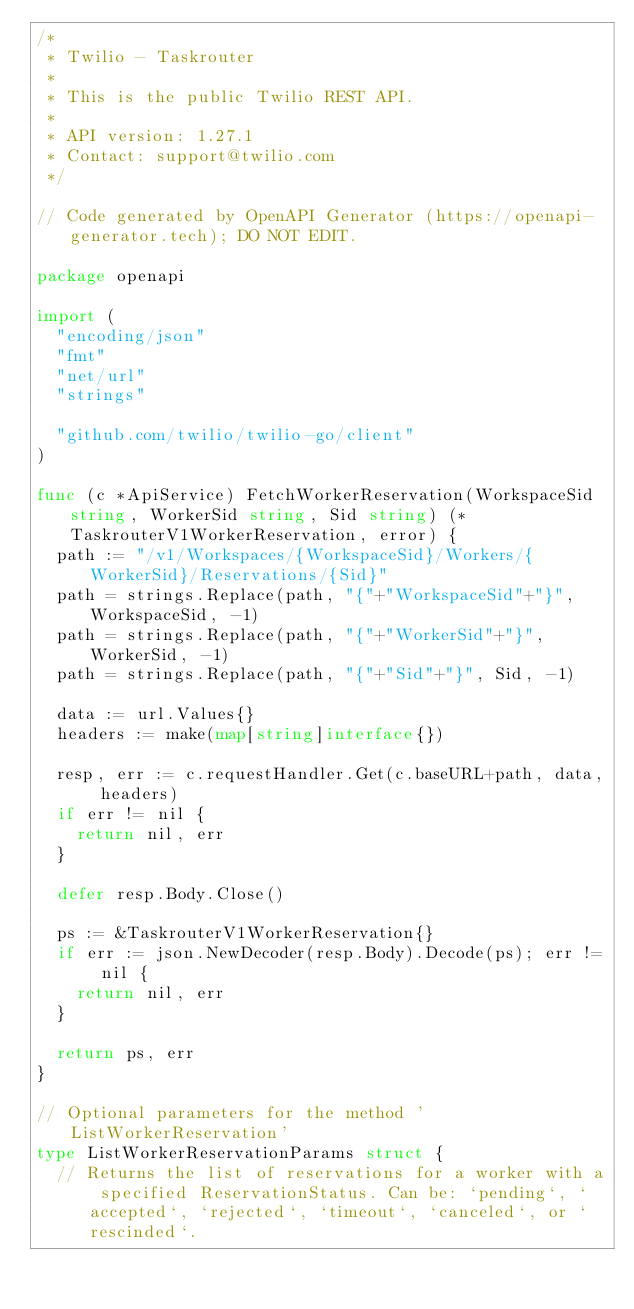Convert code to text. <code><loc_0><loc_0><loc_500><loc_500><_Go_>/*
 * Twilio - Taskrouter
 *
 * This is the public Twilio REST API.
 *
 * API version: 1.27.1
 * Contact: support@twilio.com
 */

// Code generated by OpenAPI Generator (https://openapi-generator.tech); DO NOT EDIT.

package openapi

import (
	"encoding/json"
	"fmt"
	"net/url"
	"strings"

	"github.com/twilio/twilio-go/client"
)

func (c *ApiService) FetchWorkerReservation(WorkspaceSid string, WorkerSid string, Sid string) (*TaskrouterV1WorkerReservation, error) {
	path := "/v1/Workspaces/{WorkspaceSid}/Workers/{WorkerSid}/Reservations/{Sid}"
	path = strings.Replace(path, "{"+"WorkspaceSid"+"}", WorkspaceSid, -1)
	path = strings.Replace(path, "{"+"WorkerSid"+"}", WorkerSid, -1)
	path = strings.Replace(path, "{"+"Sid"+"}", Sid, -1)

	data := url.Values{}
	headers := make(map[string]interface{})

	resp, err := c.requestHandler.Get(c.baseURL+path, data, headers)
	if err != nil {
		return nil, err
	}

	defer resp.Body.Close()

	ps := &TaskrouterV1WorkerReservation{}
	if err := json.NewDecoder(resp.Body).Decode(ps); err != nil {
		return nil, err
	}

	return ps, err
}

// Optional parameters for the method 'ListWorkerReservation'
type ListWorkerReservationParams struct {
	// Returns the list of reservations for a worker with a specified ReservationStatus. Can be: `pending`, `accepted`, `rejected`, `timeout`, `canceled`, or `rescinded`.</code> 